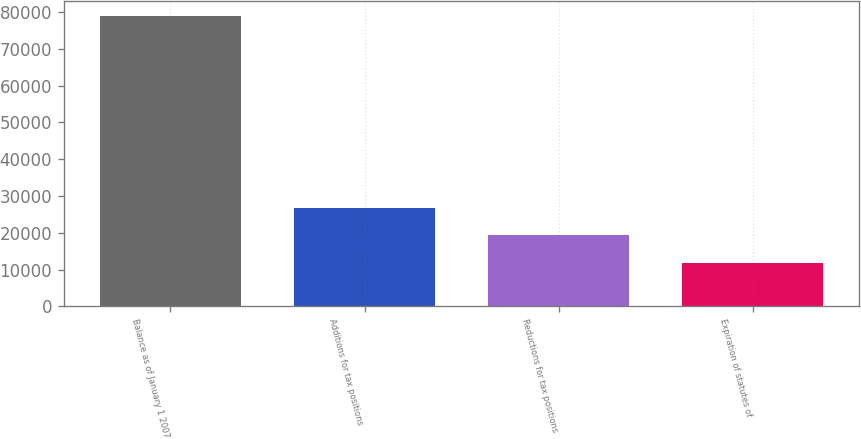Convert chart. <chart><loc_0><loc_0><loc_500><loc_500><bar_chart><fcel>Balance as of January 1 2007<fcel>Additions for tax positions<fcel>Reductions for tax positions<fcel>Expiration of statutes of<nl><fcel>79040<fcel>26781.5<fcel>19316<fcel>11850.5<nl></chart> 